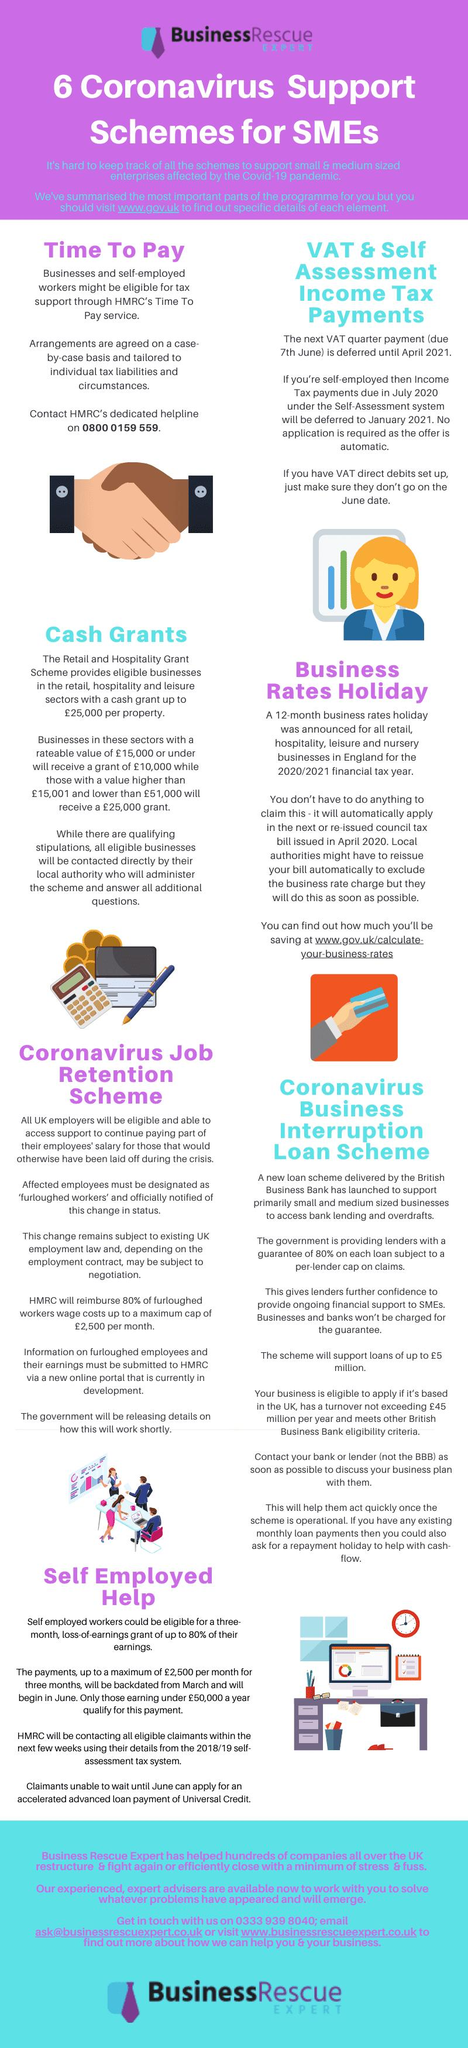Draw attention to some important aspects in this diagram. The new date for VAT quarter payment for those who are not self-employed will be in April 2021. 